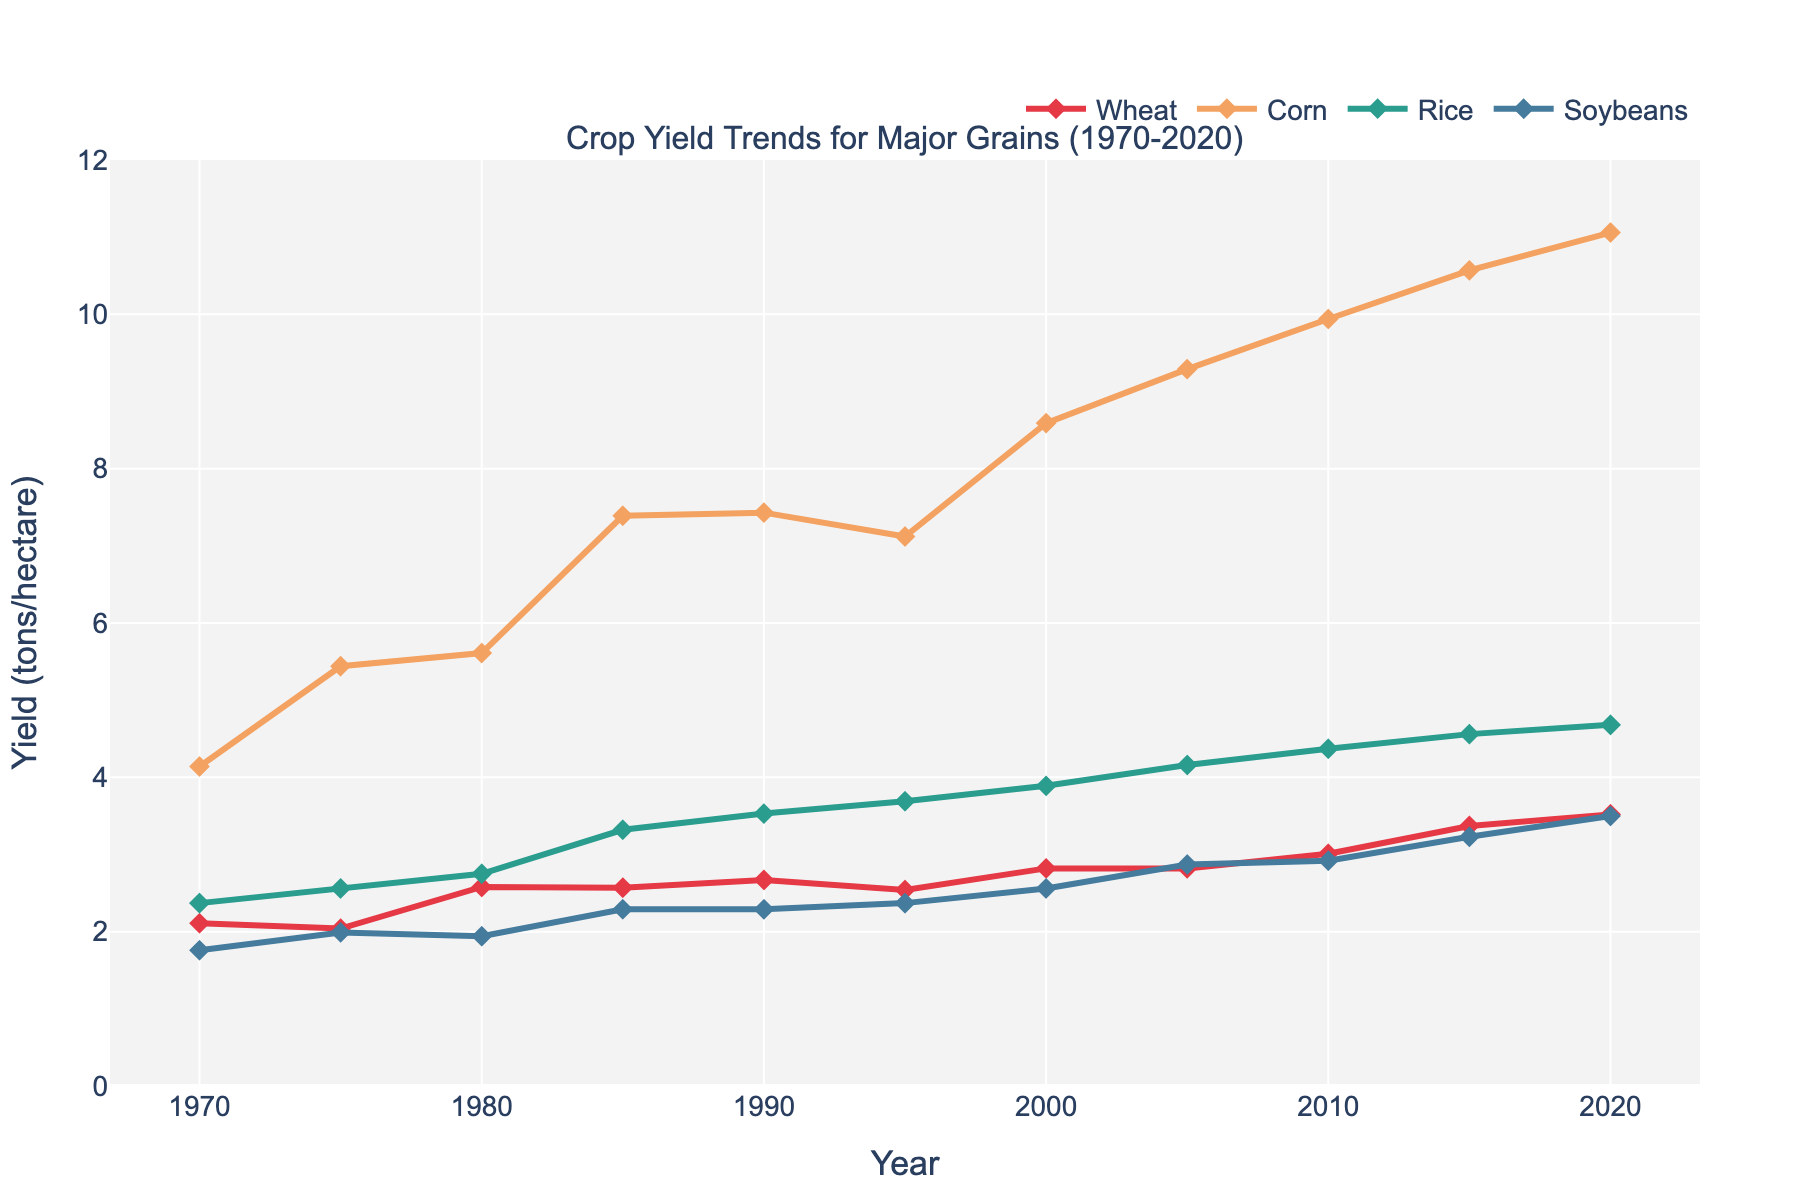Which crop had the highest yield in 2020? To obtain this answer, find the yield values for each crop in 2020 from the figure. The values are Wheat (3.52), Corn (11.06), Rice (4.68), and Soybeans (3.50). Corn has the highest yield.
Answer: Corn How has the yield of wheat changed from 1970 to 2020? Locate the yield value for wheat in 1970 (2.11) and in 2020 (3.52). Subtract the initial value from the final value: 3.52 - 2.11 = 1.41. Wheat yield increased by 1.41 tons/hectare over 50 years.
Answer: Increased by 1.41 tons/hectare Which crop has shown the most consistent yield increase over the years? Consistency can be interpreted by a steady upward trend with fewer fluctuations. By visual inspection, Corn shows a continual increasing trend with fewer significant drops, unlike the other crops.
Answer: Corn What is the average yield of soybeans over the first and last three years? Calculate the average yield for Soybeans in 1970, 1975, and 1980: (1.76 + 1.99 + 1.94)/3 = 1.8967. Calculate the average yield for Soybeans in 2015, and 2020: (3.23 + 3.50)/2 = 3.365.
Answer: 1.8967, 3.365 In which year did rice yield first exceed 4 tons/hectare? Locate the point on the line for Rice where the yield exceeds 4. This occurs between 2005 (4.16) and 2010 (4.37). The year is 2005.
Answer: 2005 Compare the yield trends of Rice and Soybeans in the last 20 years. Check the yield values from 2000 to 2020 for both crops. Rice increased from 3.89 to 4.68 showing a steady rise, while Soybeans increased from 2.56 to 3.50, also showing a rise. Both have upward trends.
Answer: Both increased What is the difference in yield for Corn between the highest and lowest points in the entire period? Find the highest yield for Corn (11.06 in 2020) and the lowest (4.14 in 1970). The difference is 11.06 - 4.14 = 6.92 tons/hectare.
Answer: 6.92 tons/hectare Which year's yield values show the greatest disparity among the crops? Visually inspect the widest range in yield values between the crops. The year 2020 shows the widest range, with wheat at 3.52, corn at 11.06, rice at 4.68, and soybeans at 3.50.
Answer: 2020 